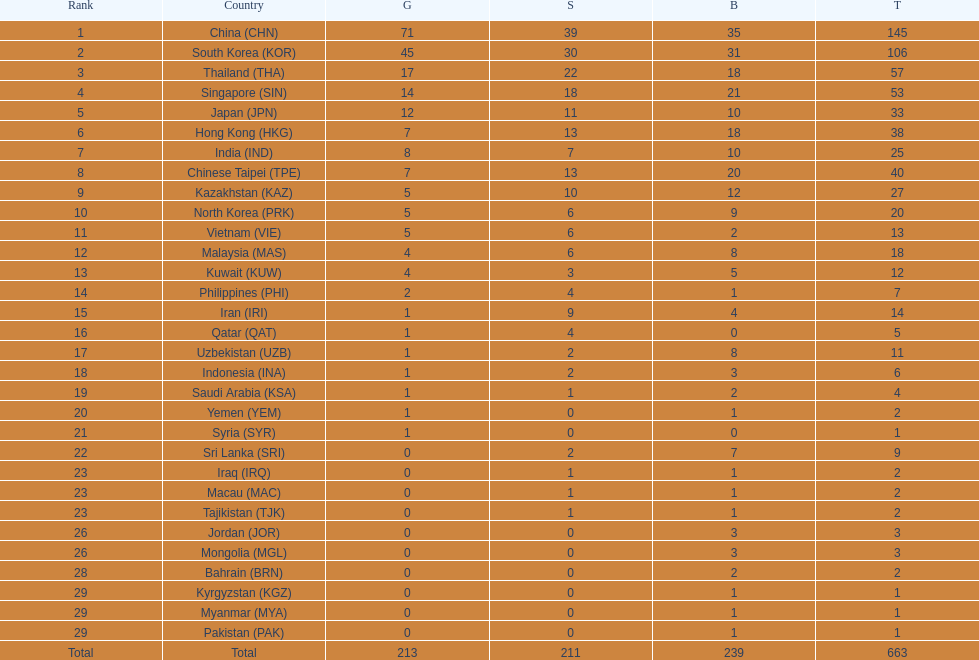What is the difference between the total amount of medals won by qatar and indonesia? 1. 